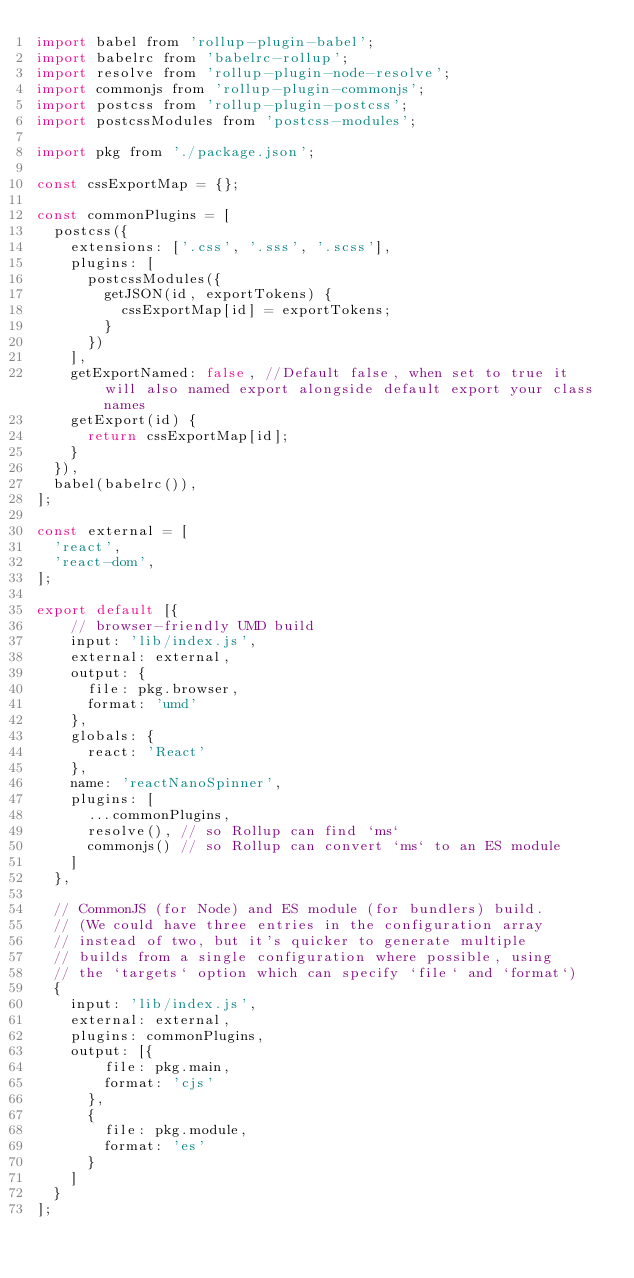Convert code to text. <code><loc_0><loc_0><loc_500><loc_500><_JavaScript_>import babel from 'rollup-plugin-babel';
import babelrc from 'babelrc-rollup';
import resolve from 'rollup-plugin-node-resolve';
import commonjs from 'rollup-plugin-commonjs';
import postcss from 'rollup-plugin-postcss';
import postcssModules from 'postcss-modules';

import pkg from './package.json';

const cssExportMap = {};

const commonPlugins = [
  postcss({
    extensions: ['.css', '.sss', '.scss'],
    plugins: [
      postcssModules({
        getJSON(id, exportTokens) {
          cssExportMap[id] = exportTokens;
        }
      })
    ],
    getExportNamed: false, //Default false, when set to true it will also named export alongside default export your class names
    getExport(id) {
      return cssExportMap[id];
    }
  }),
  babel(babelrc()),
];

const external = [
  'react',
  'react-dom',
];

export default [{
    // browser-friendly UMD build
    input: 'lib/index.js',
    external: external,
    output: {
      file: pkg.browser,
      format: 'umd'
    },
    globals: {
      react: 'React'
    },
    name: 'reactNanoSpinner',
    plugins: [
      ...commonPlugins,
      resolve(), // so Rollup can find `ms`
      commonjs() // so Rollup can convert `ms` to an ES module
    ]
  },

  // CommonJS (for Node) and ES module (for bundlers) build.
  // (We could have three entries in the configuration array
  // instead of two, but it's quicker to generate multiple
  // builds from a single configuration where possible, using
  // the `targets` option which can specify `file` and `format`)
  {
    input: 'lib/index.js',
    external: external,
    plugins: commonPlugins,
    output: [{
        file: pkg.main,
        format: 'cjs'
      },
      {
        file: pkg.module,
        format: 'es'
      }
    ]
  }
];
</code> 